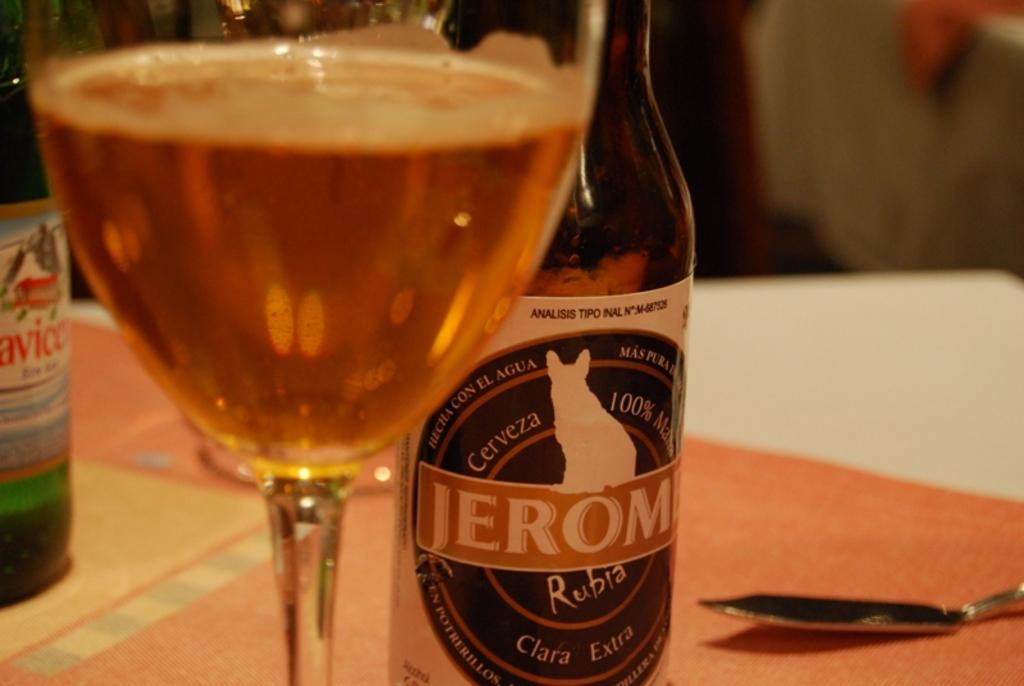<image>
Describe the image concisely. A bottle of Jerome cerveza is on a table with a spoon on its right and a glass of liquid to its left. 